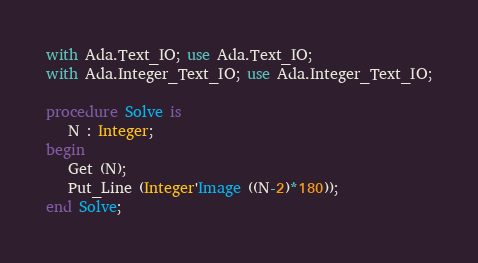Convert code to text. <code><loc_0><loc_0><loc_500><loc_500><_Ada_>with Ada.Text_IO; use Ada.Text_IO;
with Ada.Integer_Text_IO; use Ada.Integer_Text_IO;

procedure Solve is
   N : Integer;
begin
   Get (N);
   Put_Line (Integer'Image ((N-2)*180));
end Solve;</code> 